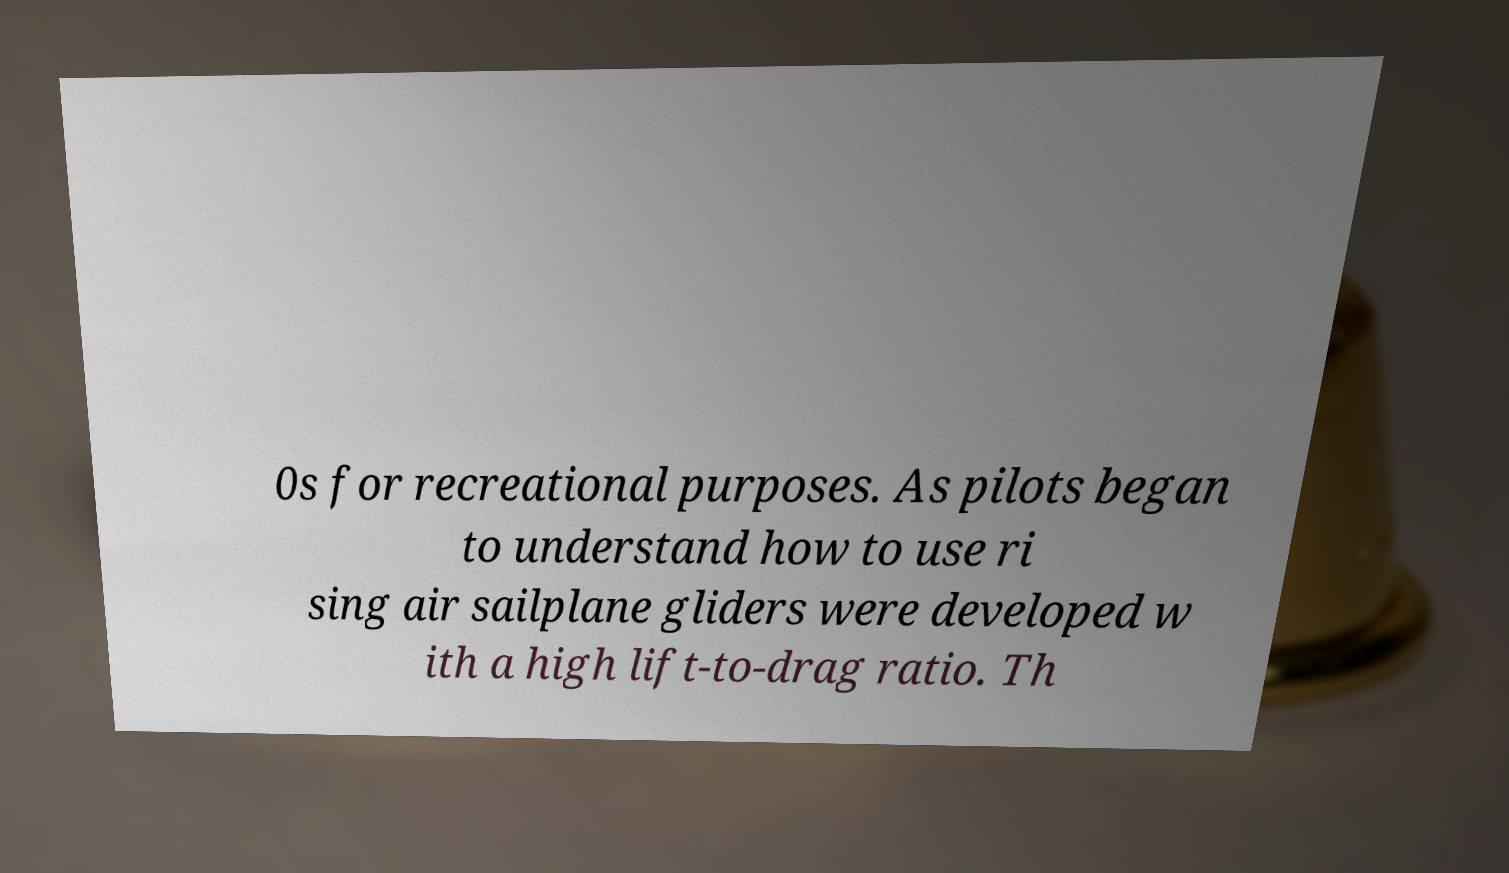Please identify and transcribe the text found in this image. 0s for recreational purposes. As pilots began to understand how to use ri sing air sailplane gliders were developed w ith a high lift-to-drag ratio. Th 